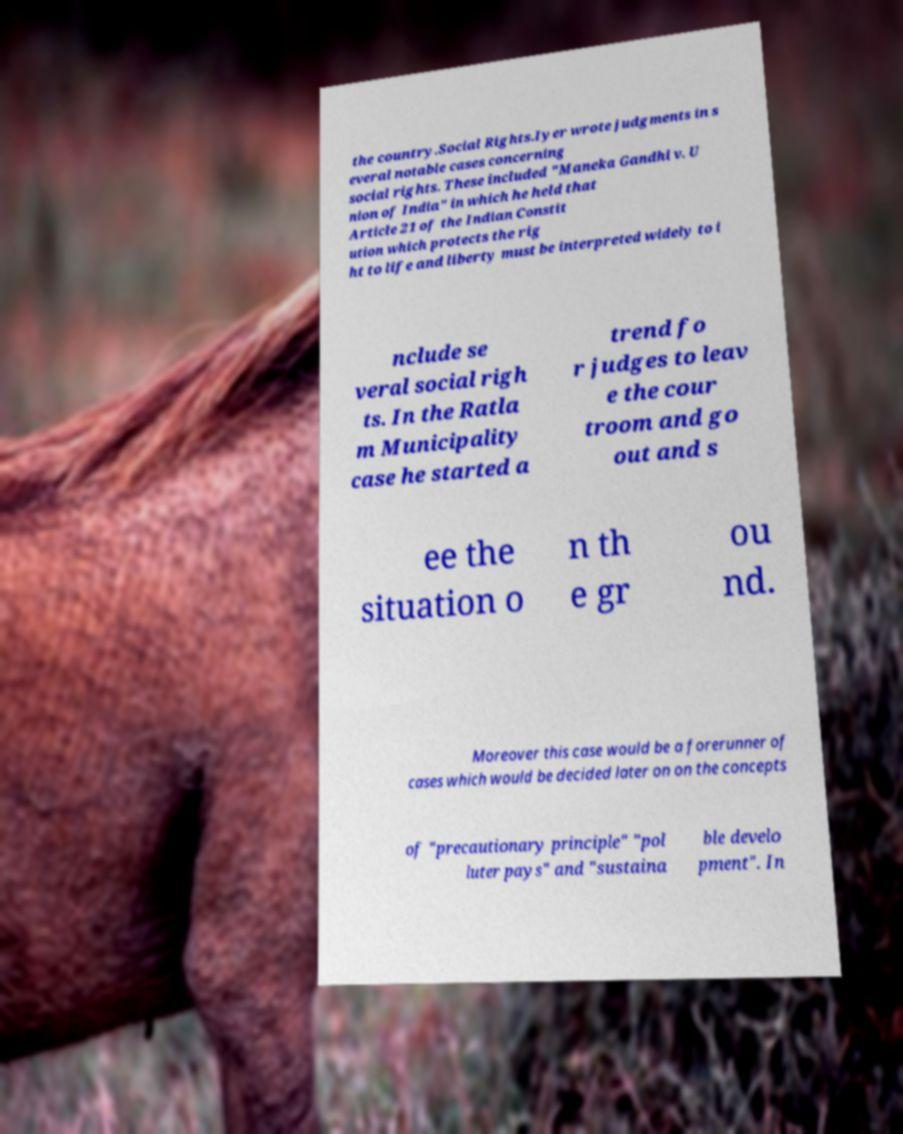Please identify and transcribe the text found in this image. the country.Social Rights.Iyer wrote judgments in s everal notable cases concerning social rights. These included "Maneka Gandhi v. U nion of India" in which he held that Article 21 of the Indian Constit ution which protects the rig ht to life and liberty must be interpreted widely to i nclude se veral social righ ts. In the Ratla m Municipality case he started a trend fo r judges to leav e the cour troom and go out and s ee the situation o n th e gr ou nd. Moreover this case would be a forerunner of cases which would be decided later on on the concepts of "precautionary principle" "pol luter pays" and "sustaina ble develo pment". In 